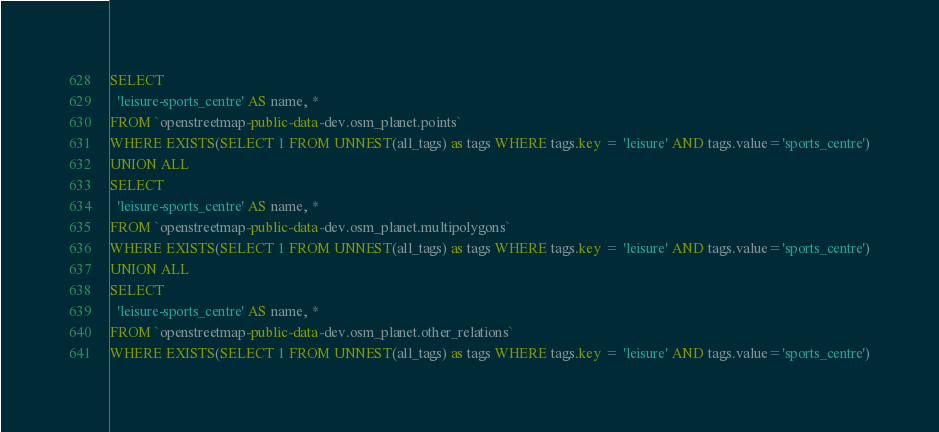Convert code to text. <code><loc_0><loc_0><loc_500><loc_500><_SQL_>SELECT
  'leisure-sports_centre' AS name, *
FROM `openstreetmap-public-data-dev.osm_planet.points`
WHERE EXISTS(SELECT 1 FROM UNNEST(all_tags) as tags WHERE tags.key = 'leisure' AND tags.value='sports_centre')
UNION ALL
SELECT
  'leisure-sports_centre' AS name, *
FROM `openstreetmap-public-data-dev.osm_planet.multipolygons`
WHERE EXISTS(SELECT 1 FROM UNNEST(all_tags) as tags WHERE tags.key = 'leisure' AND tags.value='sports_centre')
UNION ALL
SELECT
  'leisure-sports_centre' AS name, *
FROM `openstreetmap-public-data-dev.osm_planet.other_relations`
WHERE EXISTS(SELECT 1 FROM UNNEST(all_tags) as tags WHERE tags.key = 'leisure' AND tags.value='sports_centre')

</code> 